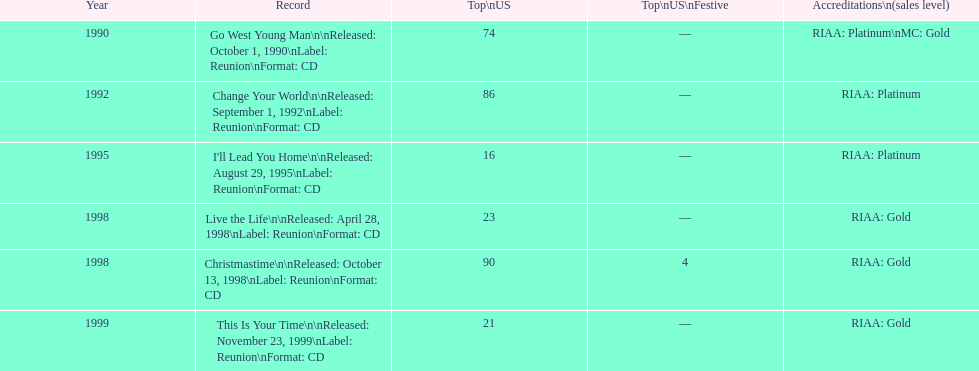Riaa: gold is only one of the certifications, but what is the other? Platinum. 